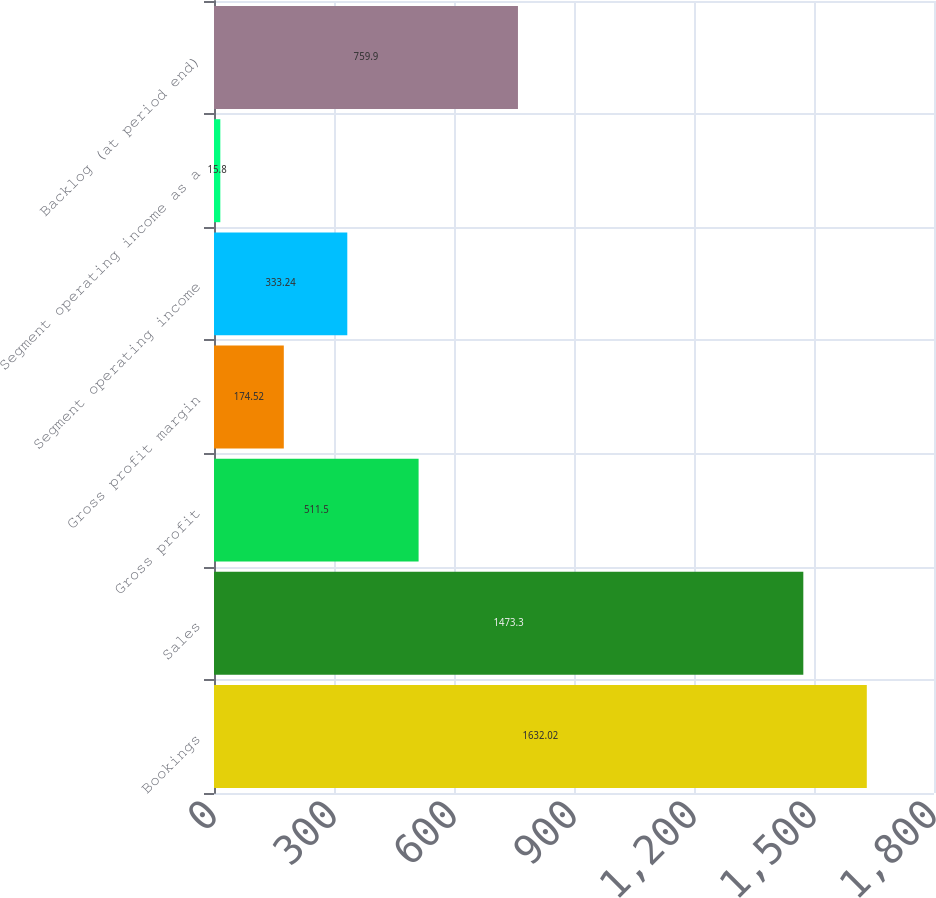<chart> <loc_0><loc_0><loc_500><loc_500><bar_chart><fcel>Bookings<fcel>Sales<fcel>Gross profit<fcel>Gross profit margin<fcel>Segment operating income<fcel>Segment operating income as a<fcel>Backlog (at period end)<nl><fcel>1632.02<fcel>1473.3<fcel>511.5<fcel>174.52<fcel>333.24<fcel>15.8<fcel>759.9<nl></chart> 